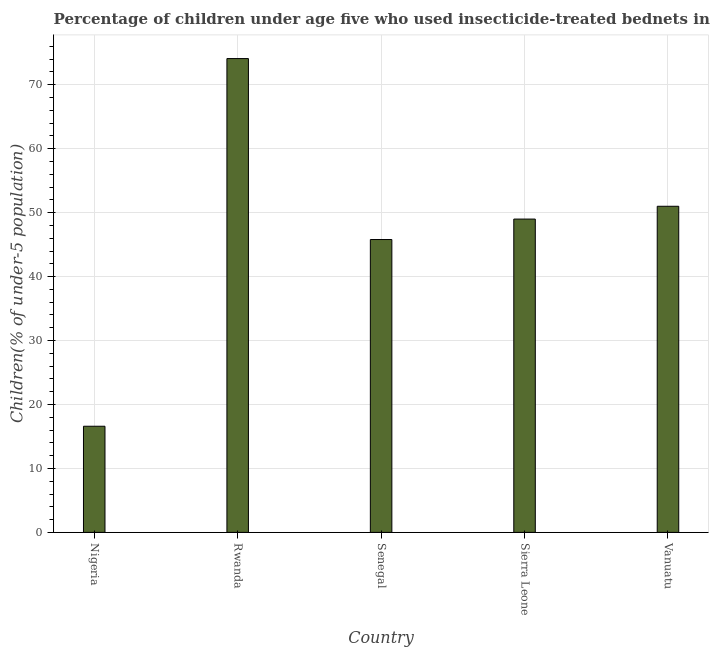Does the graph contain any zero values?
Ensure brevity in your answer.  No. What is the title of the graph?
Your answer should be very brief. Percentage of children under age five who used insecticide-treated bednets in 2013. What is the label or title of the Y-axis?
Keep it short and to the point. Children(% of under-5 population). Across all countries, what is the maximum percentage of children who use of insecticide-treated bed nets?
Ensure brevity in your answer.  74.1. In which country was the percentage of children who use of insecticide-treated bed nets maximum?
Your response must be concise. Rwanda. In which country was the percentage of children who use of insecticide-treated bed nets minimum?
Your response must be concise. Nigeria. What is the sum of the percentage of children who use of insecticide-treated bed nets?
Your answer should be very brief. 236.5. What is the average percentage of children who use of insecticide-treated bed nets per country?
Provide a succinct answer. 47.3. What is the median percentage of children who use of insecticide-treated bed nets?
Offer a very short reply. 49. What is the ratio of the percentage of children who use of insecticide-treated bed nets in Rwanda to that in Sierra Leone?
Keep it short and to the point. 1.51. Is the percentage of children who use of insecticide-treated bed nets in Senegal less than that in Vanuatu?
Provide a succinct answer. Yes. Is the difference between the percentage of children who use of insecticide-treated bed nets in Senegal and Vanuatu greater than the difference between any two countries?
Make the answer very short. No. What is the difference between the highest and the second highest percentage of children who use of insecticide-treated bed nets?
Provide a succinct answer. 23.1. Is the sum of the percentage of children who use of insecticide-treated bed nets in Nigeria and Senegal greater than the maximum percentage of children who use of insecticide-treated bed nets across all countries?
Offer a very short reply. No. What is the difference between the highest and the lowest percentage of children who use of insecticide-treated bed nets?
Your answer should be very brief. 57.5. How many bars are there?
Offer a terse response. 5. Are all the bars in the graph horizontal?
Your answer should be very brief. No. What is the difference between two consecutive major ticks on the Y-axis?
Provide a succinct answer. 10. Are the values on the major ticks of Y-axis written in scientific E-notation?
Offer a terse response. No. What is the Children(% of under-5 population) of Nigeria?
Provide a short and direct response. 16.6. What is the Children(% of under-5 population) in Rwanda?
Your answer should be compact. 74.1. What is the Children(% of under-5 population) in Senegal?
Your answer should be very brief. 45.8. What is the Children(% of under-5 population) in Sierra Leone?
Offer a very short reply. 49. What is the difference between the Children(% of under-5 population) in Nigeria and Rwanda?
Your response must be concise. -57.5. What is the difference between the Children(% of under-5 population) in Nigeria and Senegal?
Offer a terse response. -29.2. What is the difference between the Children(% of under-5 population) in Nigeria and Sierra Leone?
Provide a succinct answer. -32.4. What is the difference between the Children(% of under-5 population) in Nigeria and Vanuatu?
Make the answer very short. -34.4. What is the difference between the Children(% of under-5 population) in Rwanda and Senegal?
Provide a short and direct response. 28.3. What is the difference between the Children(% of under-5 population) in Rwanda and Sierra Leone?
Provide a succinct answer. 25.1. What is the difference between the Children(% of under-5 population) in Rwanda and Vanuatu?
Provide a short and direct response. 23.1. What is the difference between the Children(% of under-5 population) in Senegal and Sierra Leone?
Provide a short and direct response. -3.2. What is the ratio of the Children(% of under-5 population) in Nigeria to that in Rwanda?
Ensure brevity in your answer.  0.22. What is the ratio of the Children(% of under-5 population) in Nigeria to that in Senegal?
Offer a terse response. 0.36. What is the ratio of the Children(% of under-5 population) in Nigeria to that in Sierra Leone?
Provide a succinct answer. 0.34. What is the ratio of the Children(% of under-5 population) in Nigeria to that in Vanuatu?
Give a very brief answer. 0.33. What is the ratio of the Children(% of under-5 population) in Rwanda to that in Senegal?
Provide a succinct answer. 1.62. What is the ratio of the Children(% of under-5 population) in Rwanda to that in Sierra Leone?
Your response must be concise. 1.51. What is the ratio of the Children(% of under-5 population) in Rwanda to that in Vanuatu?
Offer a terse response. 1.45. What is the ratio of the Children(% of under-5 population) in Senegal to that in Sierra Leone?
Your answer should be very brief. 0.94. What is the ratio of the Children(% of under-5 population) in Senegal to that in Vanuatu?
Provide a succinct answer. 0.9. What is the ratio of the Children(% of under-5 population) in Sierra Leone to that in Vanuatu?
Make the answer very short. 0.96. 